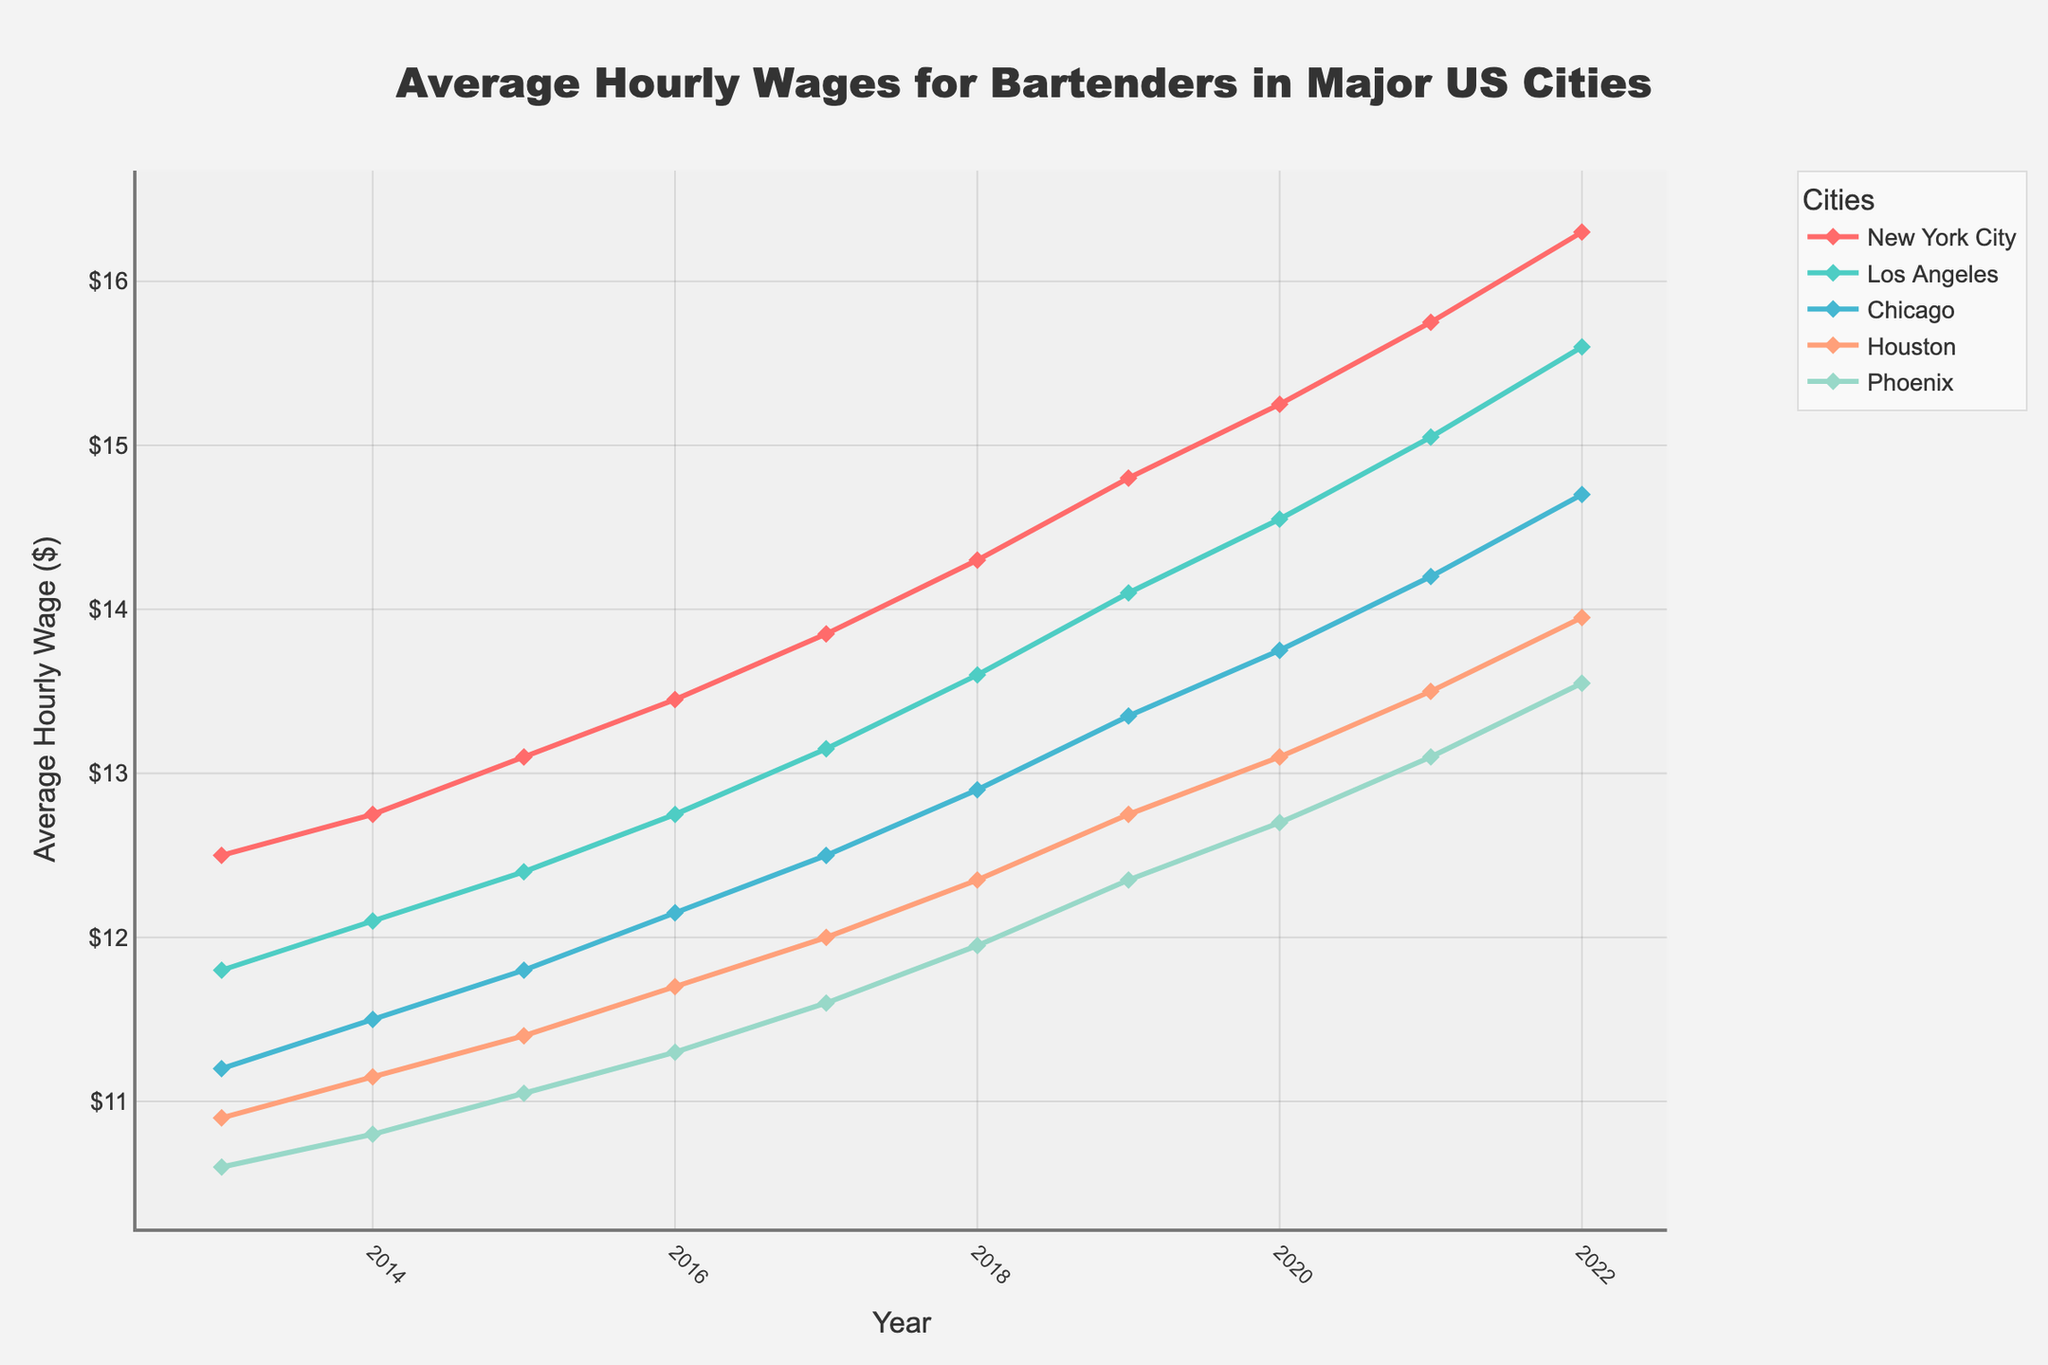Which city had the highest average hourly wage in 2022? To find the city with the highest average hourly wage in 2022, locate the 2022 data points for all cities and compare them. New York City has the highest wage at $16.30.
Answer: New York City Which city showed the most consistent rate of increase in wages from 2013 to 2022? To determine consistency, observe the smoothness and evenness of the lines representing each city from 2013 to 2022. New York City shows a steadily increasing trend with no large fluctuations.
Answer: New York City By how much did the average hourly wage in Los Angeles increase from 2013 to 2022? Calculate the difference between the 2022 and 2013 values for Los Angeles: $15.60 - $11.80.
Answer: $3.80 Which city had the lowest average hourly wage in 2017, and what was that wage? Identify the data points for 2017, compare the wages and note the lowest one. Houston had the lowest wage at $12.00.
Answer: Houston, $12.00 What is the average hourly wage for bartenders in Chicago in 2015 and 2020? For 2015, the wage is $11.80, and for 2020, it is $13.75. Calculate the average: ($11.80 + $13.75) / 2.
Answer: $12.78 Which city's wage increase between 2018 and 2019 was the highest? Compare the differences in wages between 2018 and 2019 for all cities. The increase in Phoenix is $12.35 - $11.95 = $0.40, which is the highest among the cities.
Answer: Phoenix Did Houston ever surpass the wage level of Phoenix during the years 2013 to 2022? Compare the wages of Houston and Phoenix for each year from 2013 to 2022. There is no year when Houston's wage surpasses Phoenix's wage.
Answer: No Which city has the steepest growth in wages between 2020 and 2021? Evaluate the difference between 2021 and 2020 data points for each city. Los Angeles shows the greatest increase from $14.55 to $15.05, which is $0.50.
Answer: Los Angeles In which year did New York City first exceed an average hourly wage of $15? Find the first year in the data where the wage for New York City exceeds $15. Refer to the data: in 2020, New York City’s average wage is $15.25.
Answer: 2020 What is the combined increase in average hourly wages for bartenders in New York City and Chicago from 2013 to 2022? Calculate the increase for each city from 2013 to 2022: New York City's increase is $16.30 - $12.50 = $3.80. Chicago's increase is $14.70 - $11.20 = $3.50. Sum the increases: $3.80 + $3.50.
Answer: $7.30 